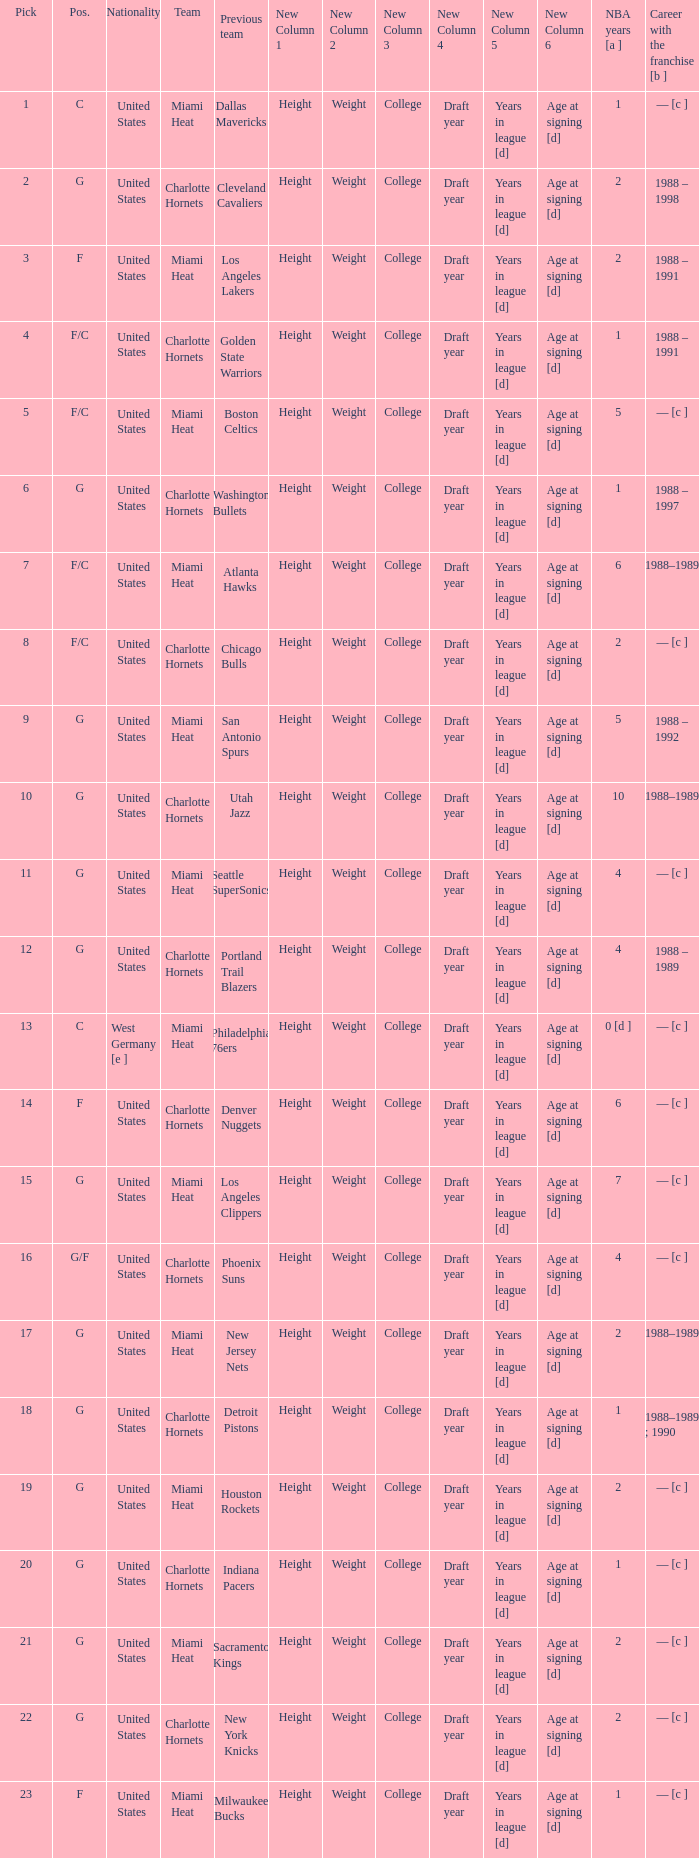Which team did the player with 4 years in the nba and a draft pick under 16 previously belong to? Seattle SuperSonics, Portland Trail Blazers. 